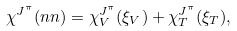Convert formula to latex. <formula><loc_0><loc_0><loc_500><loc_500>\chi ^ { J ^ { \pi } } ( n n ) = \chi ^ { J ^ { \pi } } _ { V } ( \xi _ { V } ) + \chi ^ { J ^ { \pi } } _ { T } ( \xi _ { T } ) ,</formula> 